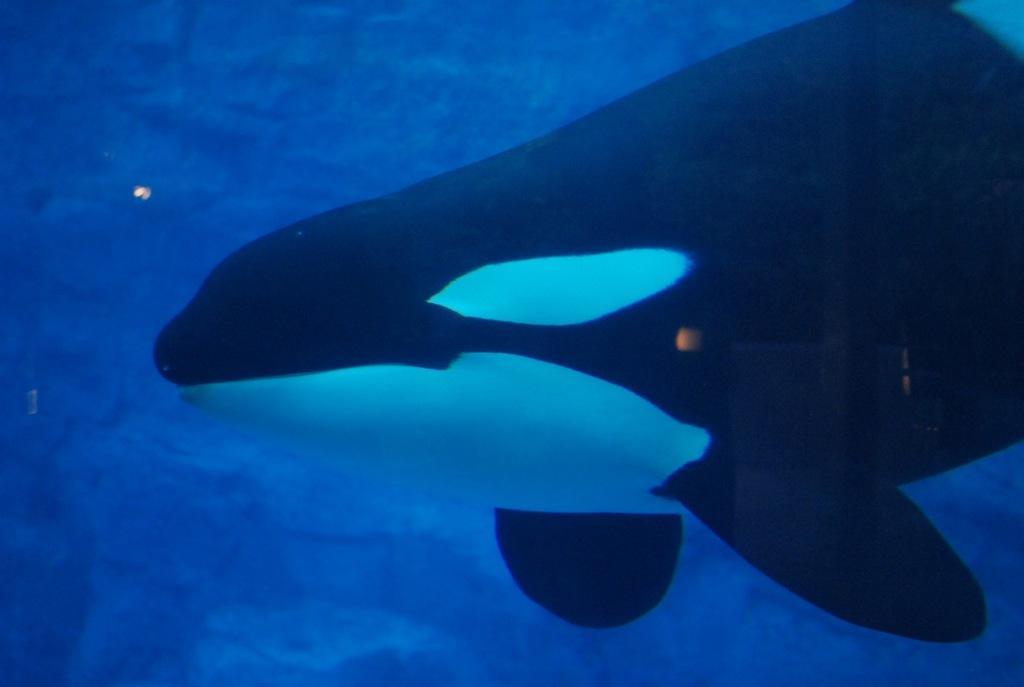Describe this image in one or two sentences. In this image, we can see an animal in the water. 